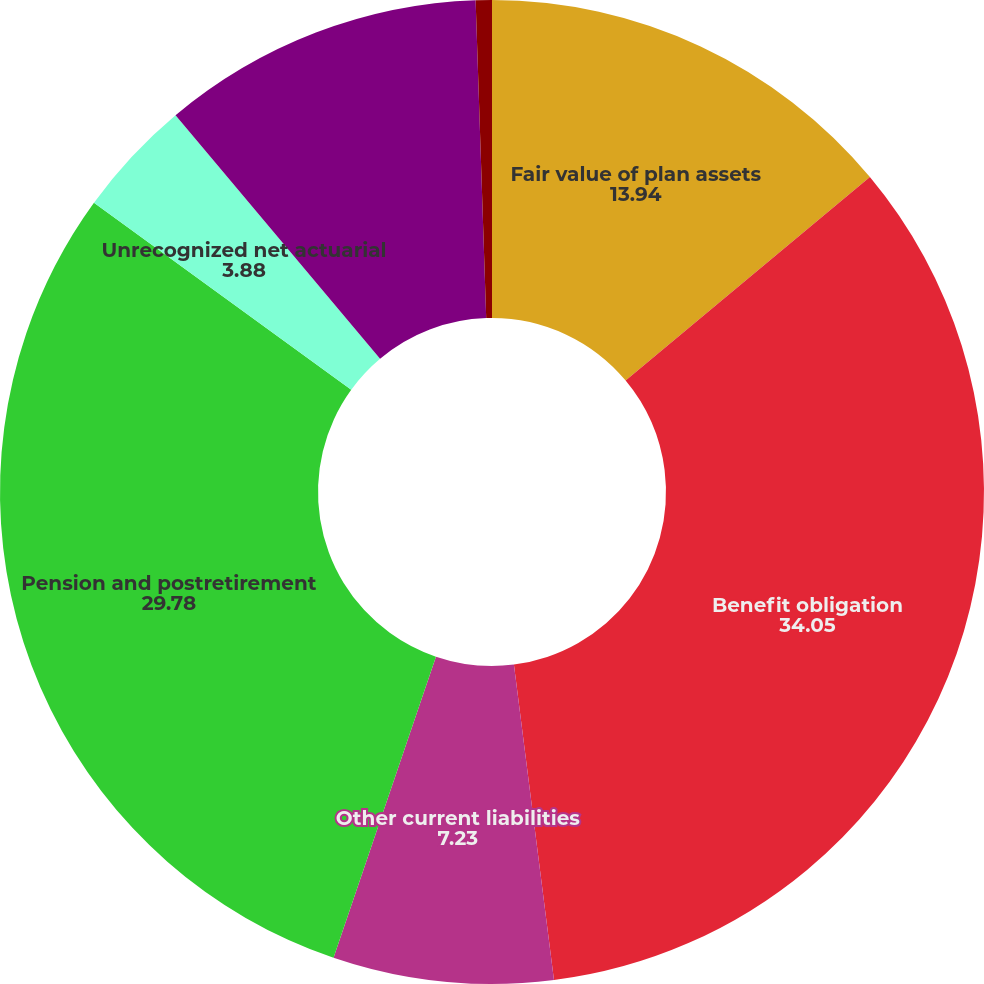Convert chart to OTSL. <chart><loc_0><loc_0><loc_500><loc_500><pie_chart><fcel>Fair value of plan assets<fcel>Benefit obligation<fcel>Other current liabilities<fcel>Pension and postretirement<fcel>Unrecognized net actuarial<fcel>Gross unrecognized cost at<fcel>Deferred tax assets<nl><fcel>13.94%<fcel>34.05%<fcel>7.23%<fcel>29.78%<fcel>3.88%<fcel>10.59%<fcel>0.53%<nl></chart> 